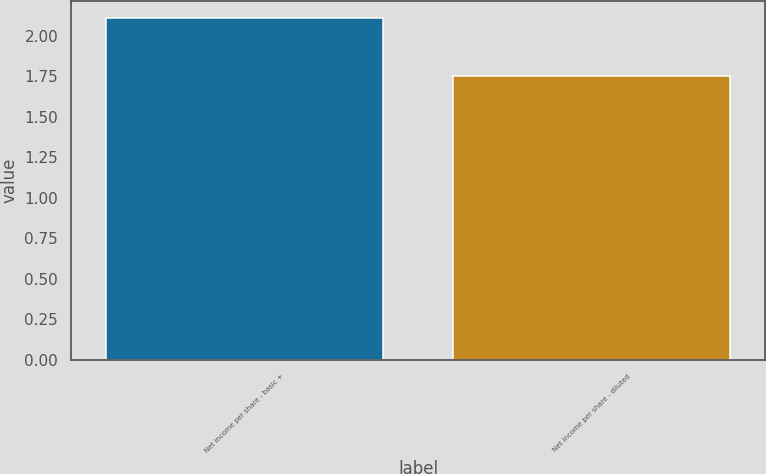<chart> <loc_0><loc_0><loc_500><loc_500><bar_chart><fcel>Net income per share - basic +<fcel>Net income per share - diluted<nl><fcel>2.11<fcel>1.75<nl></chart> 